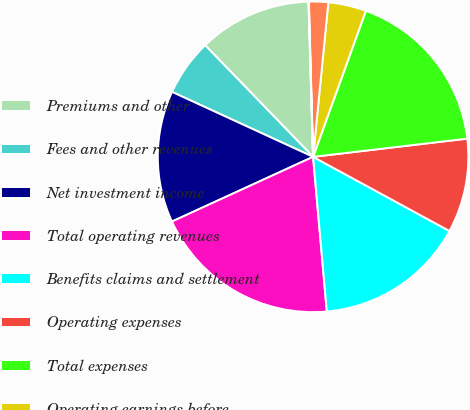Convert chart to OTSL. <chart><loc_0><loc_0><loc_500><loc_500><pie_chart><fcel>Premiums and other<fcel>Fees and other revenues<fcel>Net investment income<fcel>Total operating revenues<fcel>Benefits claims and settlement<fcel>Operating expenses<fcel>Total expenses<fcel>Operating earnings before<fcel>Income taxes (benefits)<fcel>Operating earnings (losses)<nl><fcel>11.76%<fcel>5.9%<fcel>13.71%<fcel>19.57%<fcel>15.66%<fcel>9.8%<fcel>17.61%<fcel>3.95%<fcel>2.0%<fcel>0.04%<nl></chart> 